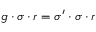Convert formula to latex. <formula><loc_0><loc_0><loc_500><loc_500>g \cdot \sigma \cdot r = \sigma ^ { \prime } \cdot \sigma \cdot r</formula> 